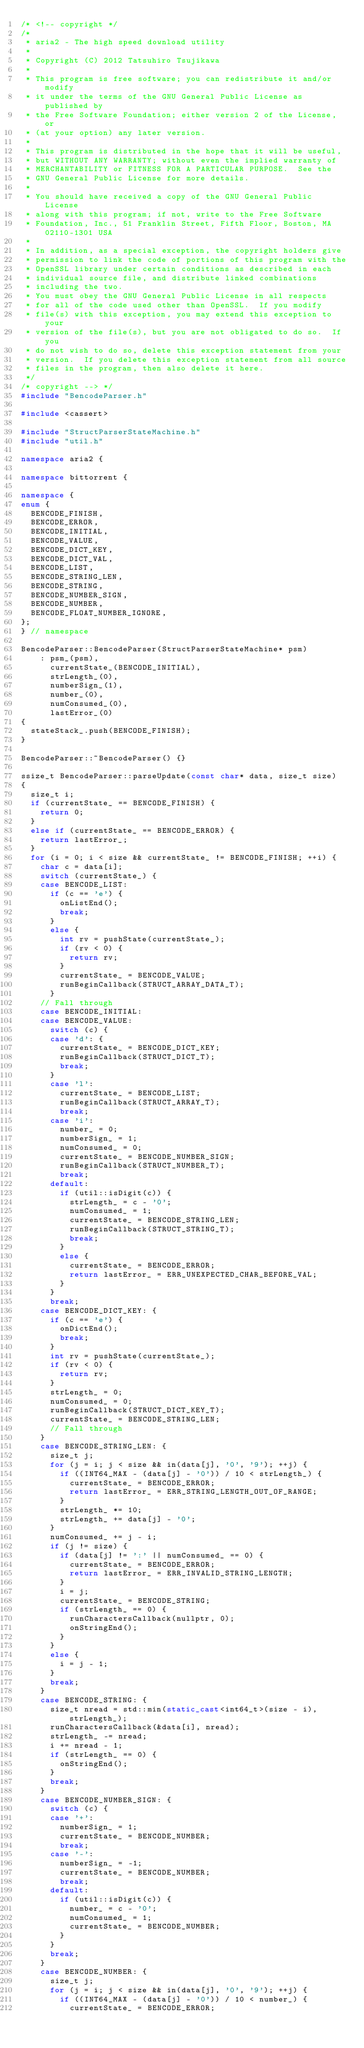Convert code to text. <code><loc_0><loc_0><loc_500><loc_500><_C++_>/* <!-- copyright */
/*
 * aria2 - The high speed download utility
 *
 * Copyright (C) 2012 Tatsuhiro Tsujikawa
 *
 * This program is free software; you can redistribute it and/or modify
 * it under the terms of the GNU General Public License as published by
 * the Free Software Foundation; either version 2 of the License, or
 * (at your option) any later version.
 *
 * This program is distributed in the hope that it will be useful,
 * but WITHOUT ANY WARRANTY; without even the implied warranty of
 * MERCHANTABILITY or FITNESS FOR A PARTICULAR PURPOSE.  See the
 * GNU General Public License for more details.
 *
 * You should have received a copy of the GNU General Public License
 * along with this program; if not, write to the Free Software
 * Foundation, Inc., 51 Franklin Street, Fifth Floor, Boston, MA 02110-1301 USA
 *
 * In addition, as a special exception, the copyright holders give
 * permission to link the code of portions of this program with the
 * OpenSSL library under certain conditions as described in each
 * individual source file, and distribute linked combinations
 * including the two.
 * You must obey the GNU General Public License in all respects
 * for all of the code used other than OpenSSL.  If you modify
 * file(s) with this exception, you may extend this exception to your
 * version of the file(s), but you are not obligated to do so.  If you
 * do not wish to do so, delete this exception statement from your
 * version.  If you delete this exception statement from all source
 * files in the program, then also delete it here.
 */
/* copyright --> */
#include "BencodeParser.h"

#include <cassert>

#include "StructParserStateMachine.h"
#include "util.h"

namespace aria2 {

namespace bittorrent {

namespace {
enum {
  BENCODE_FINISH,
  BENCODE_ERROR,
  BENCODE_INITIAL,
  BENCODE_VALUE,
  BENCODE_DICT_KEY,
  BENCODE_DICT_VAL,
  BENCODE_LIST,
  BENCODE_STRING_LEN,
  BENCODE_STRING,
  BENCODE_NUMBER_SIGN,
  BENCODE_NUMBER,
  BENCODE_FLOAT_NUMBER_IGNORE,
};
} // namespace

BencodeParser::BencodeParser(StructParserStateMachine* psm)
    : psm_(psm),
      currentState_(BENCODE_INITIAL),
      strLength_(0),
      numberSign_(1),
      number_(0),
      numConsumed_(0),
      lastError_(0)
{
  stateStack_.push(BENCODE_FINISH);
}

BencodeParser::~BencodeParser() {}

ssize_t BencodeParser::parseUpdate(const char* data, size_t size)
{
  size_t i;
  if (currentState_ == BENCODE_FINISH) {
    return 0;
  }
  else if (currentState_ == BENCODE_ERROR) {
    return lastError_;
  }
  for (i = 0; i < size && currentState_ != BENCODE_FINISH; ++i) {
    char c = data[i];
    switch (currentState_) {
    case BENCODE_LIST:
      if (c == 'e') {
        onListEnd();
        break;
      }
      else {
        int rv = pushState(currentState_);
        if (rv < 0) {
          return rv;
        }
        currentState_ = BENCODE_VALUE;
        runBeginCallback(STRUCT_ARRAY_DATA_T);
      }
    // Fall through
    case BENCODE_INITIAL:
    case BENCODE_VALUE:
      switch (c) {
      case 'd': {
        currentState_ = BENCODE_DICT_KEY;
        runBeginCallback(STRUCT_DICT_T);
        break;
      }
      case 'l':
        currentState_ = BENCODE_LIST;
        runBeginCallback(STRUCT_ARRAY_T);
        break;
      case 'i':
        number_ = 0;
        numberSign_ = 1;
        numConsumed_ = 0;
        currentState_ = BENCODE_NUMBER_SIGN;
        runBeginCallback(STRUCT_NUMBER_T);
        break;
      default:
        if (util::isDigit(c)) {
          strLength_ = c - '0';
          numConsumed_ = 1;
          currentState_ = BENCODE_STRING_LEN;
          runBeginCallback(STRUCT_STRING_T);
          break;
        }
        else {
          currentState_ = BENCODE_ERROR;
          return lastError_ = ERR_UNEXPECTED_CHAR_BEFORE_VAL;
        }
      }
      break;
    case BENCODE_DICT_KEY: {
      if (c == 'e') {
        onDictEnd();
        break;
      }
      int rv = pushState(currentState_);
      if (rv < 0) {
        return rv;
      }
      strLength_ = 0;
      numConsumed_ = 0;
      runBeginCallback(STRUCT_DICT_KEY_T);
      currentState_ = BENCODE_STRING_LEN;
      // Fall through
    }
    case BENCODE_STRING_LEN: {
      size_t j;
      for (j = i; j < size && in(data[j], '0', '9'); ++j) {
        if ((INT64_MAX - (data[j] - '0')) / 10 < strLength_) {
          currentState_ = BENCODE_ERROR;
          return lastError_ = ERR_STRING_LENGTH_OUT_OF_RANGE;
        }
        strLength_ *= 10;
        strLength_ += data[j] - '0';
      }
      numConsumed_ += j - i;
      if (j != size) {
        if (data[j] != ':' || numConsumed_ == 0) {
          currentState_ = BENCODE_ERROR;
          return lastError_ = ERR_INVALID_STRING_LENGTH;
        }
        i = j;
        currentState_ = BENCODE_STRING;
        if (strLength_ == 0) {
          runCharactersCallback(nullptr, 0);
          onStringEnd();
        }
      }
      else {
        i = j - 1;
      }
      break;
    }
    case BENCODE_STRING: {
      size_t nread = std::min(static_cast<int64_t>(size - i), strLength_);
      runCharactersCallback(&data[i], nread);
      strLength_ -= nread;
      i += nread - 1;
      if (strLength_ == 0) {
        onStringEnd();
      }
      break;
    }
    case BENCODE_NUMBER_SIGN: {
      switch (c) {
      case '+':
        numberSign_ = 1;
        currentState_ = BENCODE_NUMBER;
        break;
      case '-':
        numberSign_ = -1;
        currentState_ = BENCODE_NUMBER;
        break;
      default:
        if (util::isDigit(c)) {
          number_ = c - '0';
          numConsumed_ = 1;
          currentState_ = BENCODE_NUMBER;
        }
      }
      break;
    }
    case BENCODE_NUMBER: {
      size_t j;
      for (j = i; j < size && in(data[j], '0', '9'); ++j) {
        if ((INT64_MAX - (data[j] - '0')) / 10 < number_) {
          currentState_ = BENCODE_ERROR;</code> 